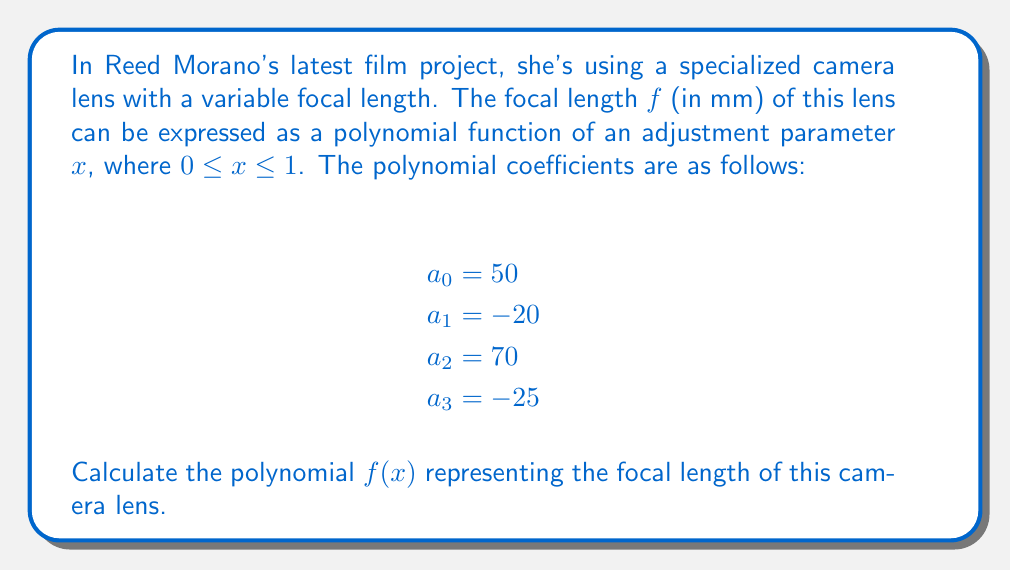Teach me how to tackle this problem. To calculate the polynomial representing the focal length, we need to construct a polynomial function using the given coefficients. The general form of a 3rd-degree polynomial is:

$$f(x) = a_0 + a_1x + a_2x^2 + a_3x^3$$

Where:
$a_0$ is the constant term
$a_1$ is the coefficient of $x$
$a_2$ is the coefficient of $x^2$
$a_3$ is the coefficient of $x^3$

Substituting the given values:

$a_0 = 50$
$a_1 = -20$
$a_2 = 70$
$a_3 = -25$

We can now construct the polynomial:

$$f(x) = 50 + (-20)x + 70x^2 + (-25)x^3$$

Simplifying the expression:

$$f(x) = 50 - 20x + 70x^2 - 25x^3$$

This polynomial represents the focal length of the camera lens in millimeters as a function of the adjustment parameter $x$.
Answer: $f(x) = 50 - 20x + 70x^2 - 25x^3$ 